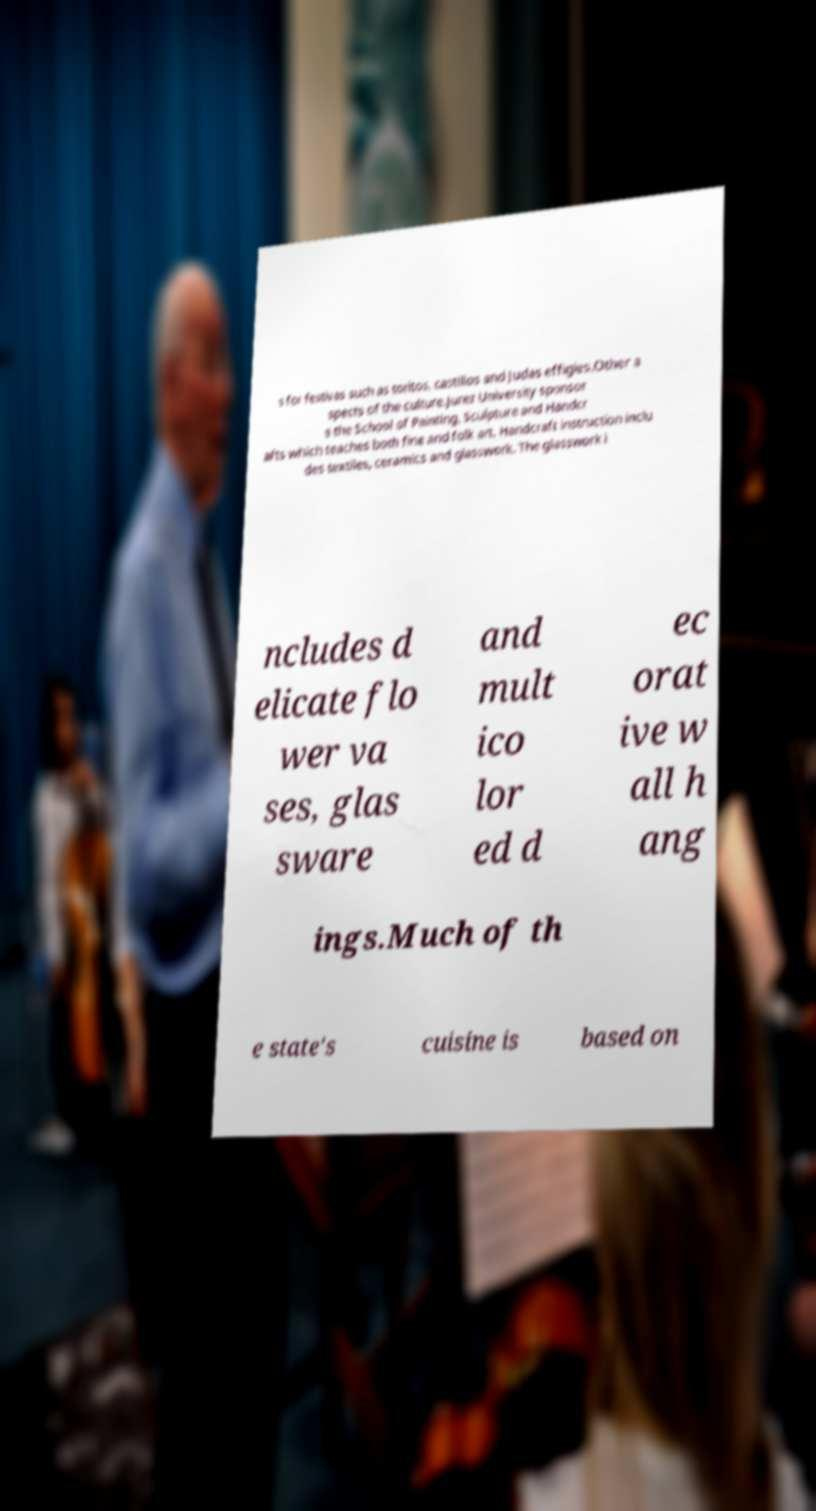Can you read and provide the text displayed in the image?This photo seems to have some interesting text. Can you extract and type it out for me? s for festivas such as toritos, castillos and Judas effigies.Other a spects of the culture.Jurez University sponsor s the School of Painting, Sculpture and Handcr afts which teaches both fine and folk art. Handcraft instruction inclu des textiles, ceramics and glasswork. The glasswork i ncludes d elicate flo wer va ses, glas sware and mult ico lor ed d ec orat ive w all h ang ings.Much of th e state's cuisine is based on 